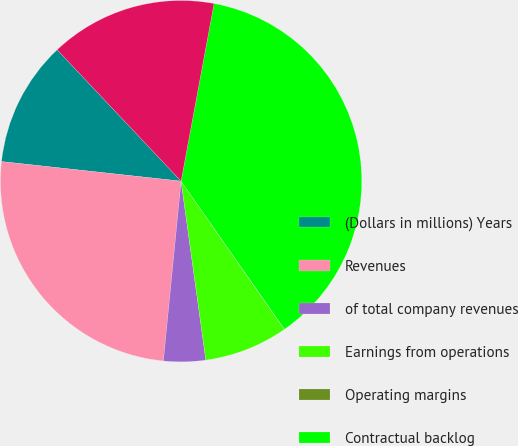Convert chart to OTSL. <chart><loc_0><loc_0><loc_500><loc_500><pie_chart><fcel>(Dollars in millions) Years<fcel>Revenues<fcel>of total company revenues<fcel>Earnings from operations<fcel>Operating margins<fcel>Contractual backlog<fcel>Unobligated backlog<nl><fcel>11.23%<fcel>25.17%<fcel>3.75%<fcel>7.49%<fcel>0.02%<fcel>37.38%<fcel>14.96%<nl></chart> 